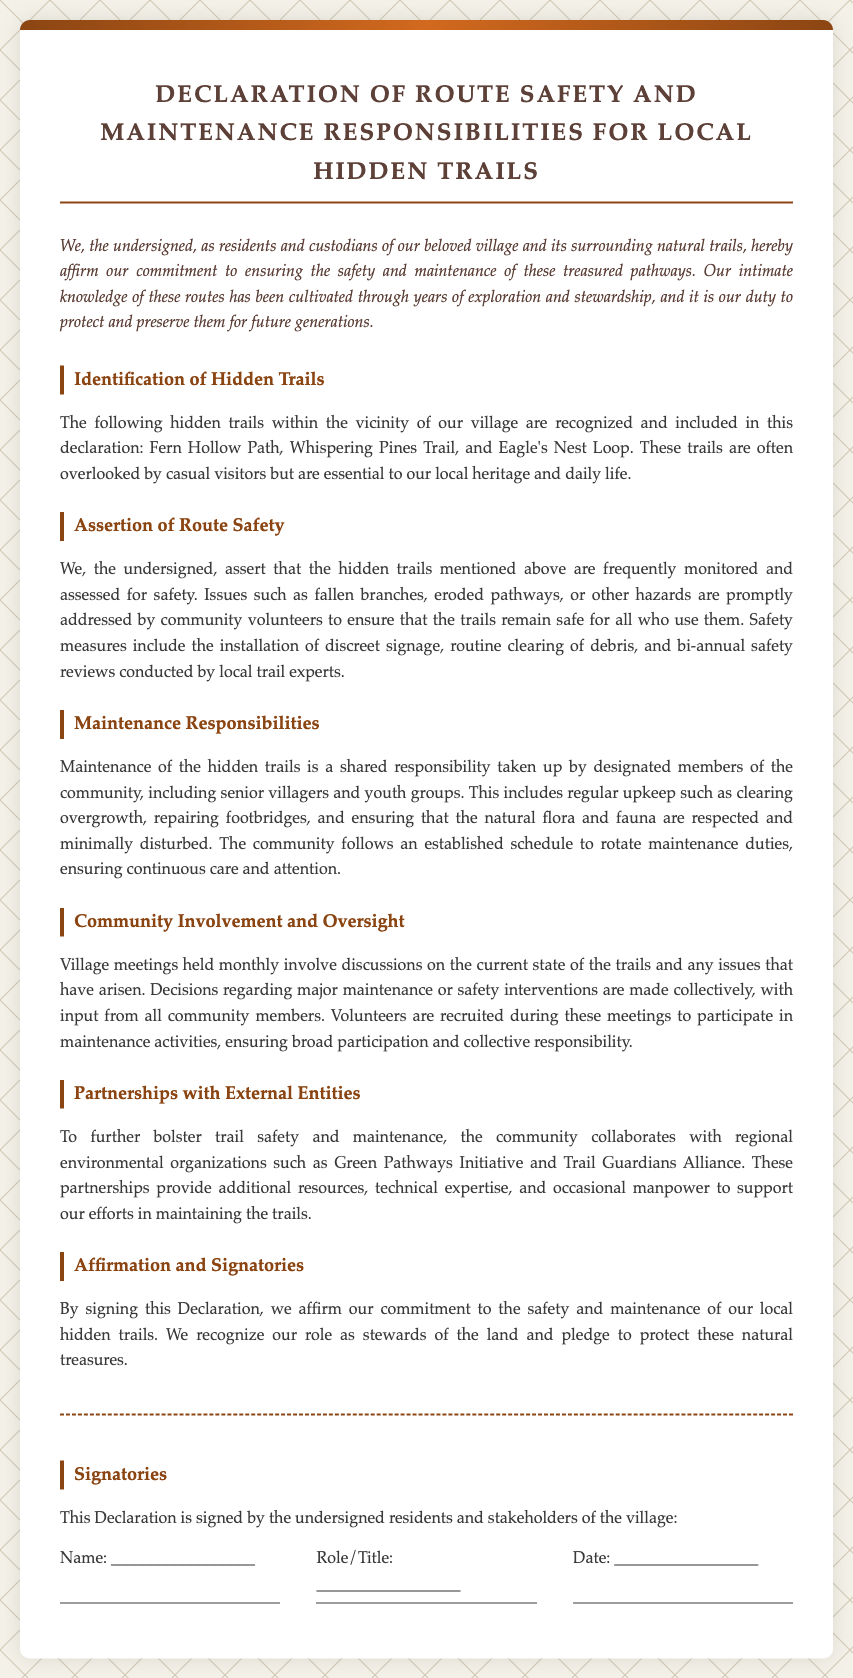What are the names of the hidden trails? The document lists the hidden trails that are included in the declaration, which are Fern Hollow Path, Whispering Pines Trail, and Eagle's Nest Loop.
Answer: Fern Hollow Path, Whispering Pines Trail, Eagle's Nest Loop How often are safety reviews conducted? The document states that safety reviews are conducted bi-annually to ensure the trails' safety.
Answer: Bi-annual Who participates in the maintenance duties? The document specifies that maintenance responsibilities are taken up by designated community members, including senior villagers and youth groups.
Answer: Senior villagers and youth groups What organizations partner with the community for trail maintenance? The document mentions two organizations that collaborate with the community: Green Pathways Initiative and Trail Guardians Alliance.
Answer: Green Pathways Initiative, Trail Guardians Alliance What is the purpose of the declaration? The declaration aims to affirm the community's commitment to the safety and maintenance of local hidden trails, highlighting their role as stewards of the land.
Answer: To affirm commitment to safety and maintenance How often are village meetings held? The document indicates that village meetings are held monthly to discuss the trails' state and maintenance issues.
Answer: Monthly 